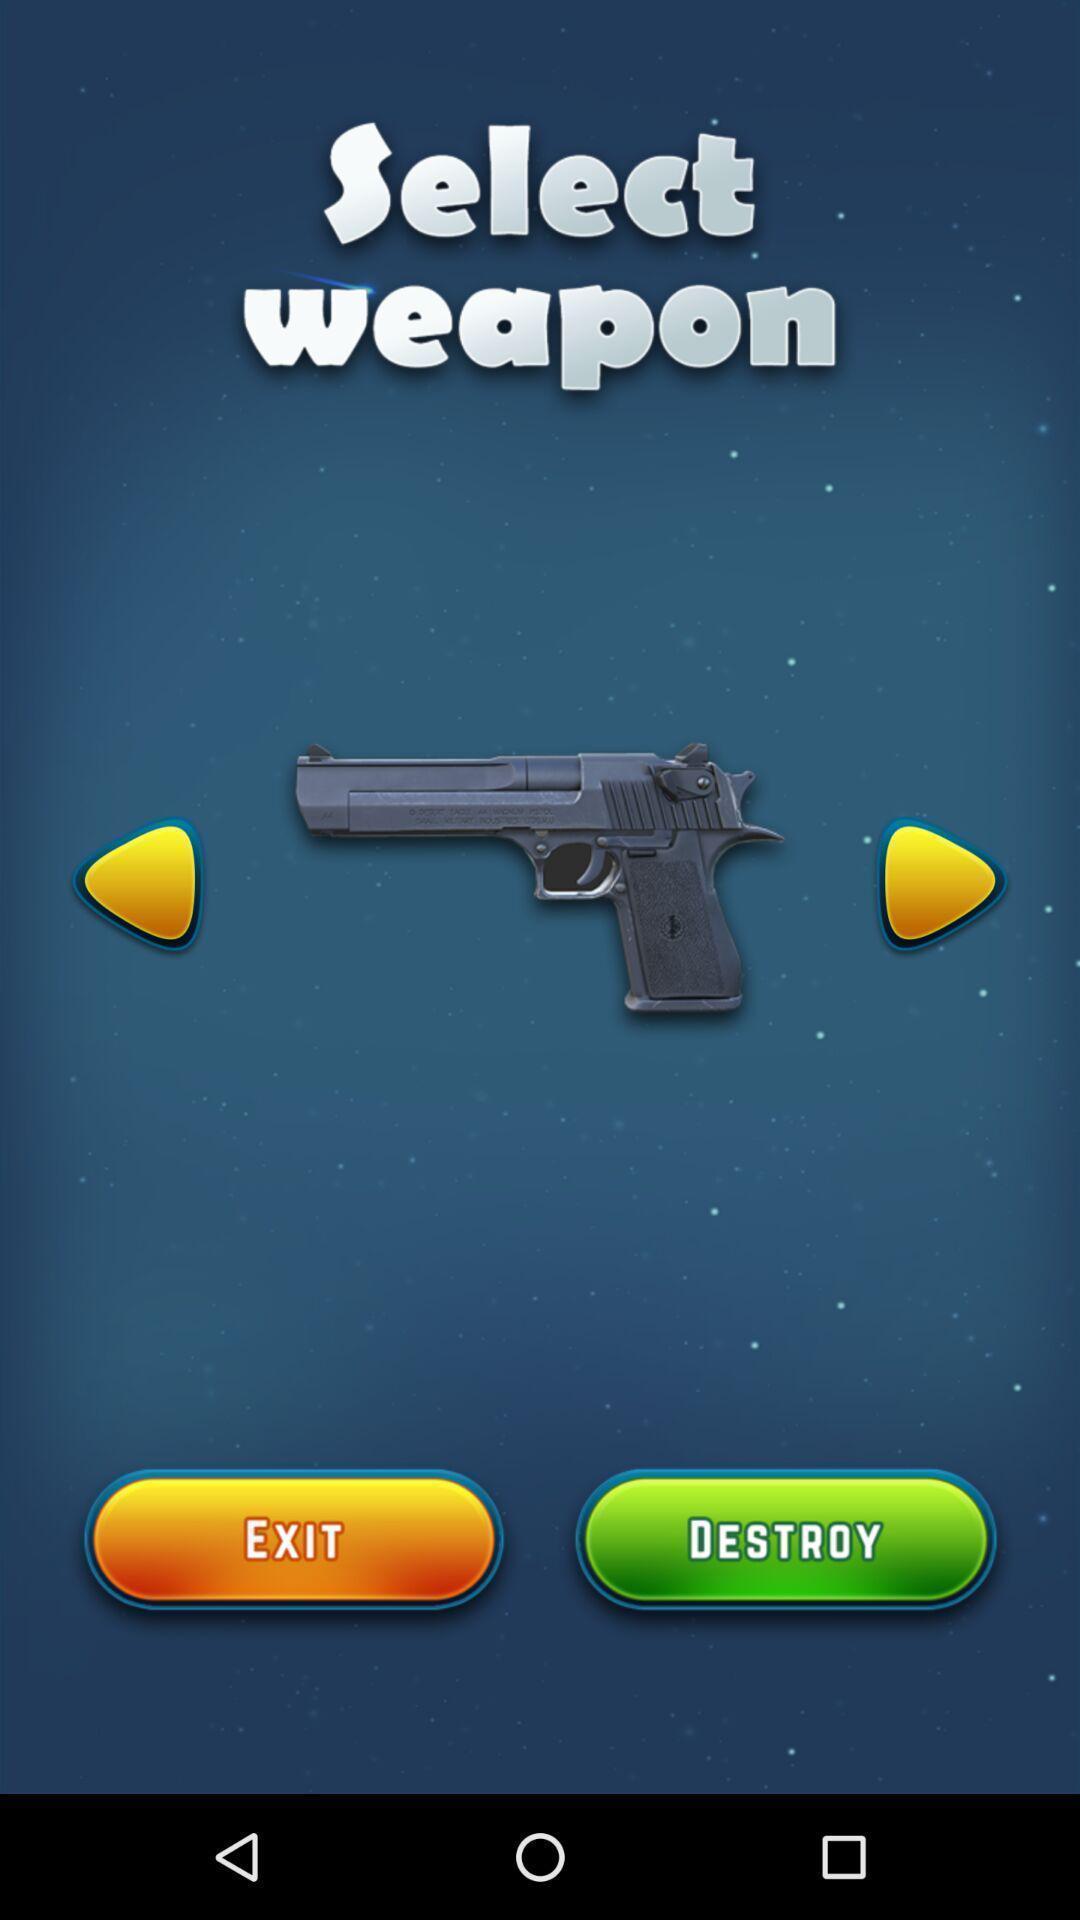Give me a summary of this screen capture. Page displaying with select a weapon in game application. 